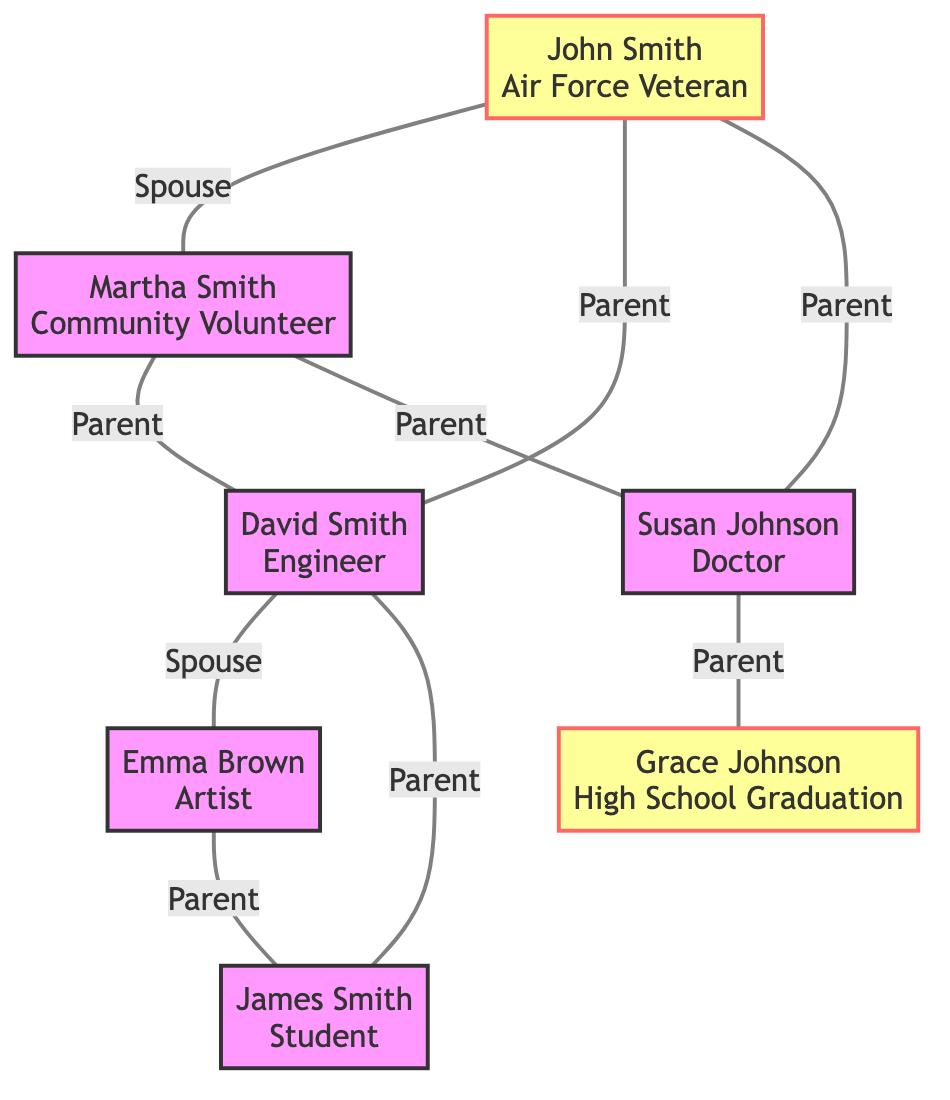What is the milestone of John Smith? The diagram shows that John Smith has the milestone labeled "Air Force Veteran." This is directly connected to his node in the diagram.
Answer: Air Force Veteran Who are the parents of David Smith? The diagram shows connections labeled as "Parent" leading from John Smith and Martha Smith to David Smith. Therefore, both John and Martha are his parents.
Answer: John Smith, Martha Smith How many edges are in the diagram? The diagram contains connections, or edges, that denote relationships. By counting, we find there are 8 edges that connect the nodes.
Answer: 8 What is the relationship between Emma Brown and James Smith? The diagram indicates a connection labeled "Parent" from both Emma Brown and David Smith to James Smith, signifying that Emma is a parent to James.
Answer: Parent Which family member is a Doctor? The diagram states that Susan Johnson has the milestone "Doctor" indicated on her node. This is clearly labeled.
Answer: Susan Johnson How many children do John and Martha Smith have? By examining the connections from John Smith and Martha Smith labeled "Parent," we find there are two offspring: David Smith and Susan Johnson.
Answer: 2 Which family member has a milestone associated with graduation? Looking at the nodes, Grace Johnson has the milestone labeled "High School Graduation," directly associated with her node.
Answer: Grace Johnson Who is the spouse of David Smith? The relationship labeled "Spouse" indicates that Emma Brown is the spouse of David Smith, as shown in the diagram.
Answer: Emma Brown What is the relationship between Susan Johnson and Grace Johnson? The diagram shows that Susan Johnson is connected as a "Parent" to Grace Johnson, indicating that Susan is Grace's parent.
Answer: Parent 